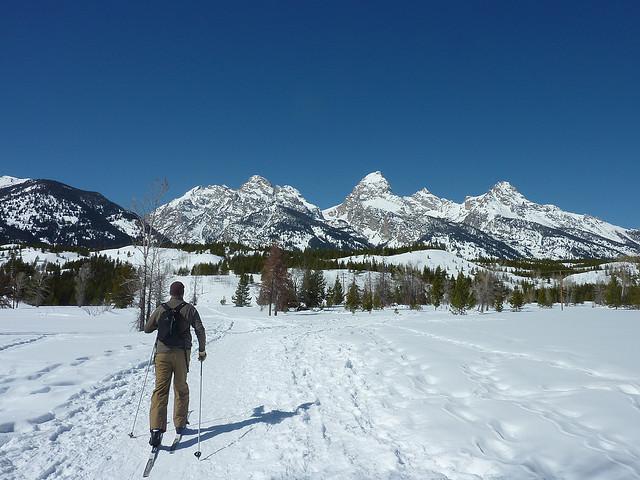What kind of snow skiing is the man doing?
Be succinct. Cross country. What sport is he doing?
Short answer required. Skiing. What is the person doing?
Be succinct. Skiing. Is this person skiing towards the camera?
Write a very short answer. No. How many people are in the picture?
Write a very short answer. 1. Do they have a car?
Give a very brief answer. No. How do people get up the mountain?
Answer briefly. Walk. Where is the skier?
Be succinct. Snow. What color is the backpack?
Answer briefly. Black. Is this hill too steep for most non-expert skiers?
Keep it brief. No. Is the man skiing?
Write a very short answer. Yes. Where was this picture taken?
Be succinct. Mountains. Is the man going uphill or downhill?
Quick response, please. Down. What color are his ski boats?
Answer briefly. Black. How much weight is the man carrying in the backpack?
Quick response, please. 10 pounds. Did the person fall?
Give a very brief answer. No. Are there mountains in the backdrop?
Write a very short answer. Yes. What is attached to this person's feet?
Be succinct. Skis. Is this at a high elevation?
Be succinct. Yes. What sport is the person playing?
Keep it brief. Skiing. 